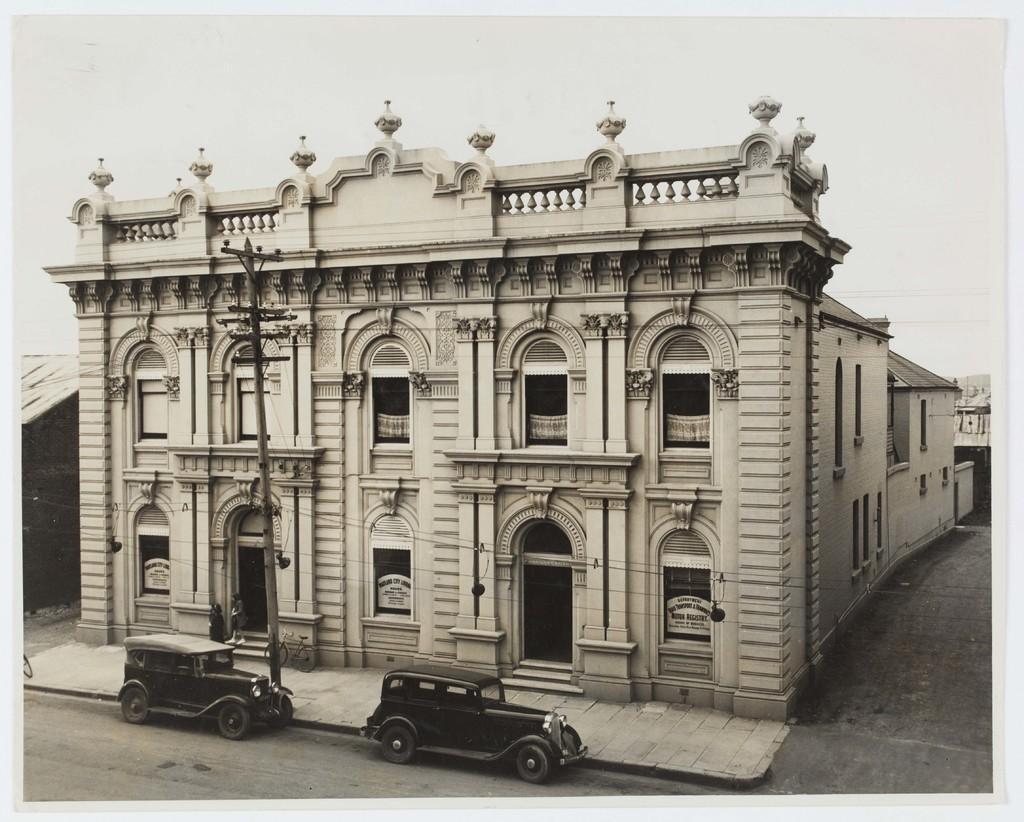Describe this image in one or two sentences. This picture is an edited picture. In the foreground there is a building and there are two persons standing on the stair case and there is a pole and bicycle on the footpath and there are two vehicles on the road. On the left and on the right side of the image there are buildings. At the top there is sky. At the bottom there is a road. 